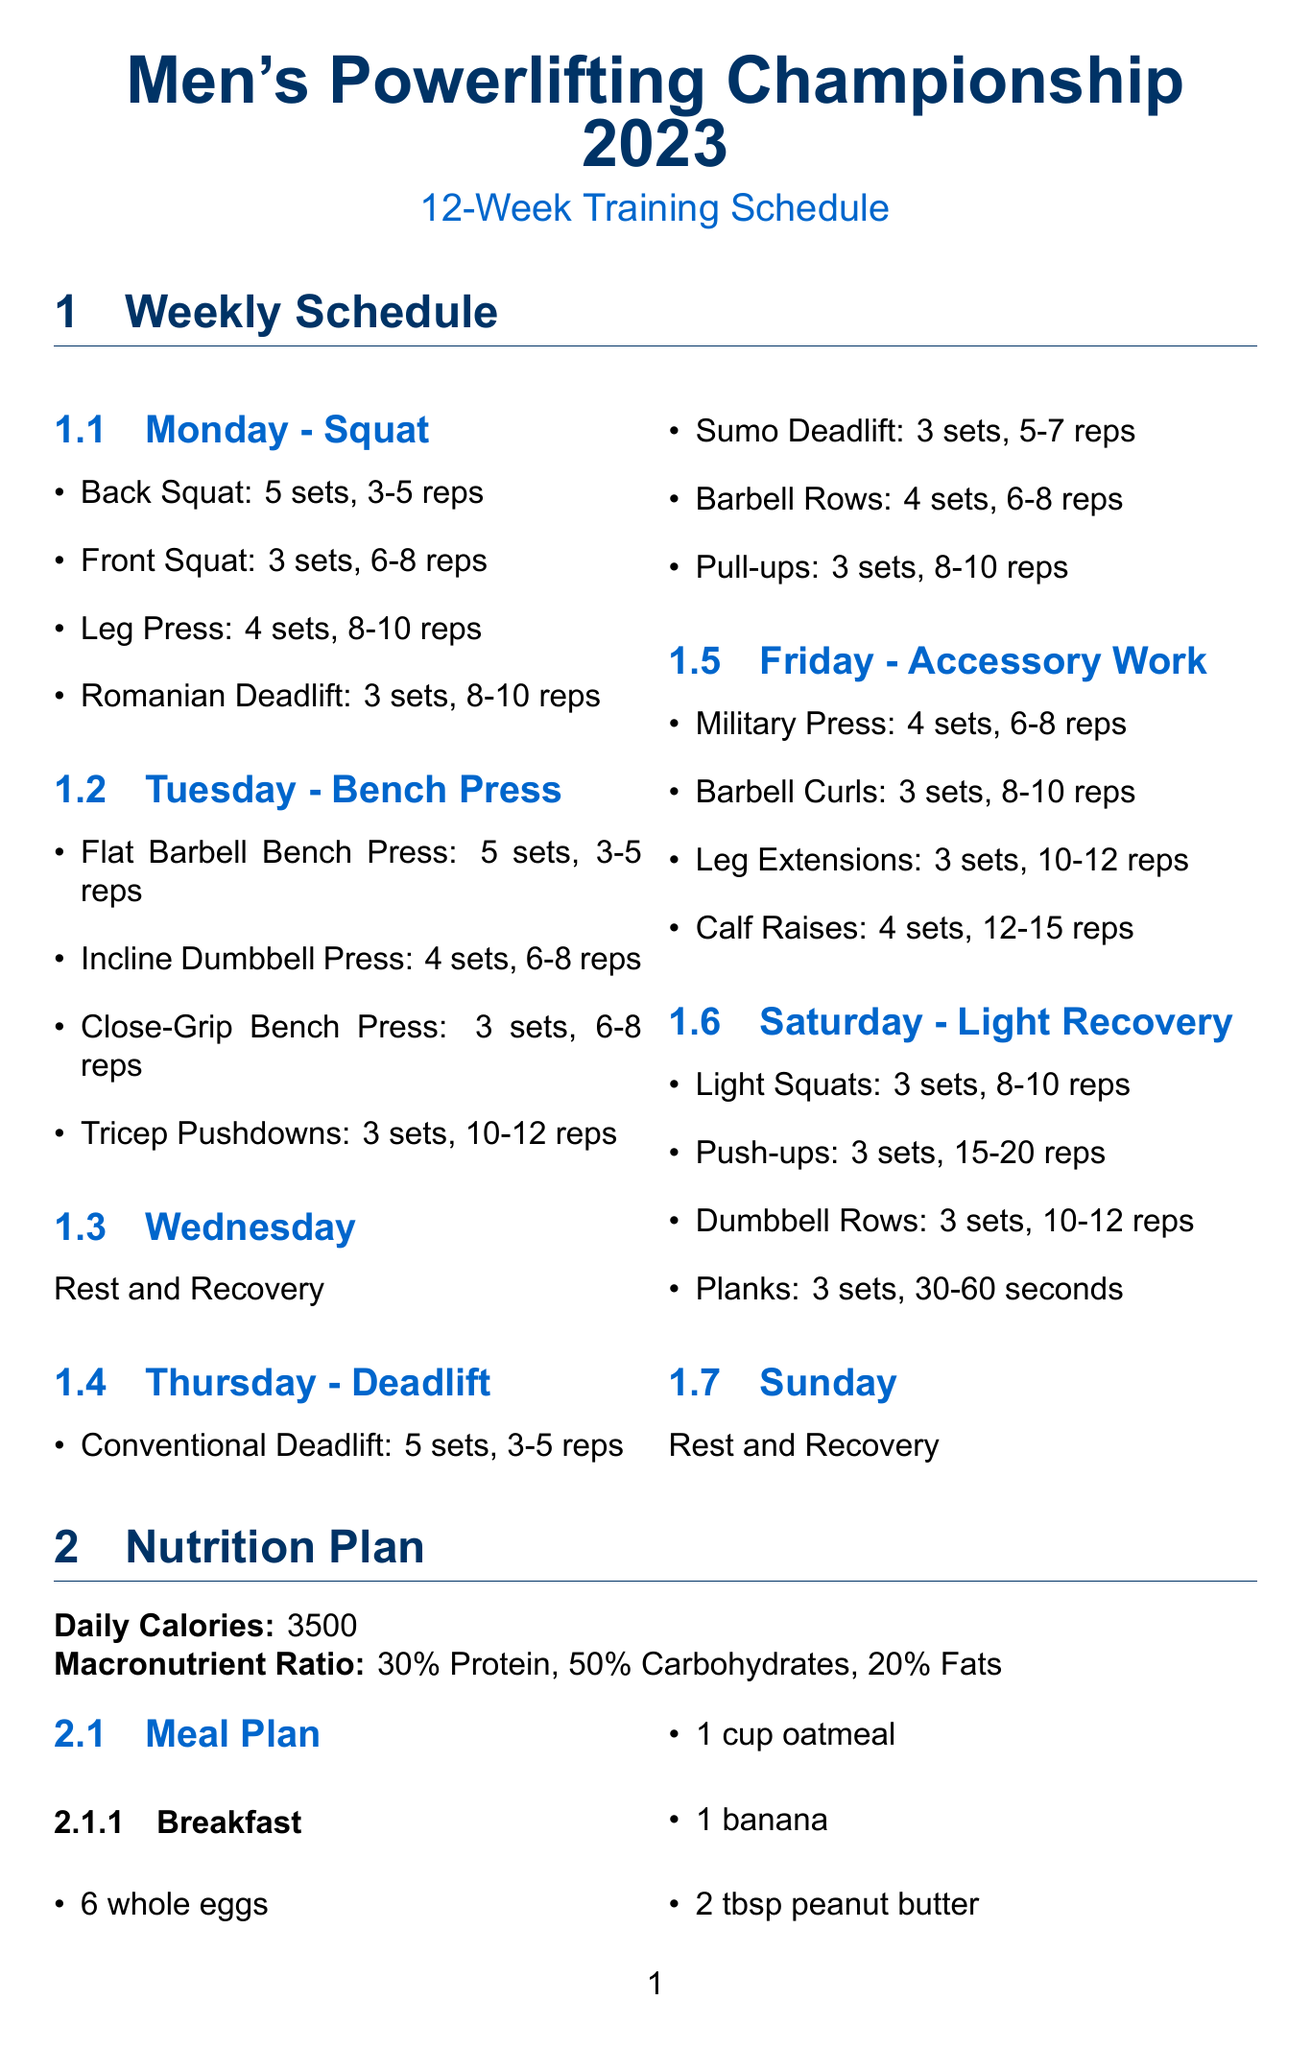What is the duration of the training schedule? The training schedule lasts for 12 weeks.
Answer: 12 weeks How many sets and reps for the Back Squat? The document states that the Back Squat consists of 5 sets with 3-5 reps.
Answer: 5 sets, 3-5 reps What should be consumed for breakfast? The breakfast meal plan includes 6 whole eggs, 1 cup oatmeal, 1 banana, and 2 tbsp peanut butter.
Answer: 6 whole eggs, 1 cup oatmeal, 1 banana, 2 tbsp peanut butter How many daily calories are recommended? The nutrition plan specifies a daily caloric intake of 3500 calories.
Answer: 3500 What is the protein ratio in the macronutrient plan? The macronutrient ratio specifies that protein should constitute 30% of the diet.
Answer: 30% What activities are suggested for the day before the competition? Suggested activities include light mobility work, visualization exercises, and equipment check.
Answer: Light mobility work, visualization exercises, equipment check What is recommended for pre-workout meal? The pre-workout meal includes 1 banana, 1 scoop whey protein, and 1 cup Greek yogurt.
Answer: 1 banana, 1 scoop whey protein, 1 cup Greek yogurt What is the focus of Thursday's training? On Thursday, the focus of the training is Deadlift.
Answer: Deadlift How should hydration be managed during peak week? The document advises increasing water intake and then tapering off 24 hours before weigh-in.
Answer: Increase water intake, then taper off 24 hours before weigh-in 